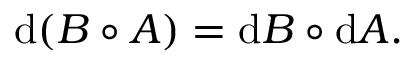<formula> <loc_0><loc_0><loc_500><loc_500>d ( B \circ A ) = d B \circ d A .</formula> 